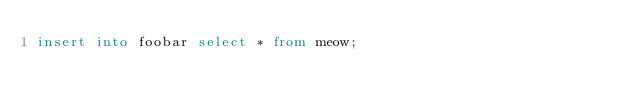Convert code to text. <code><loc_0><loc_0><loc_500><loc_500><_SQL_>insert into foobar select * from meow;</code> 